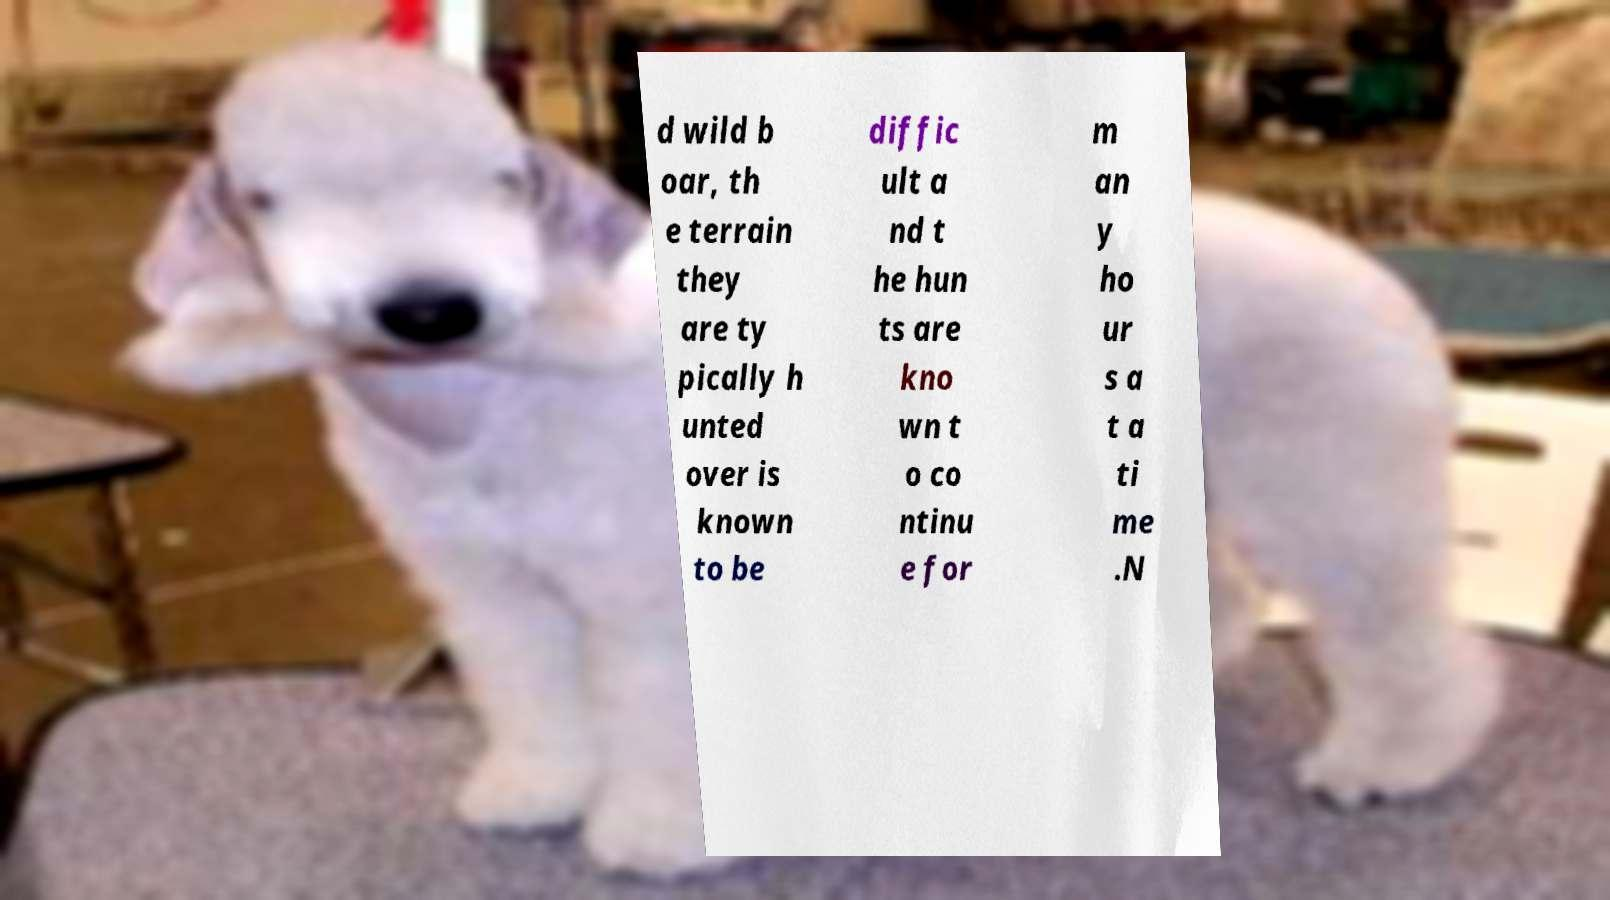Can you read and provide the text displayed in the image?This photo seems to have some interesting text. Can you extract and type it out for me? d wild b oar, th e terrain they are ty pically h unted over is known to be diffic ult a nd t he hun ts are kno wn t o co ntinu e for m an y ho ur s a t a ti me .N 